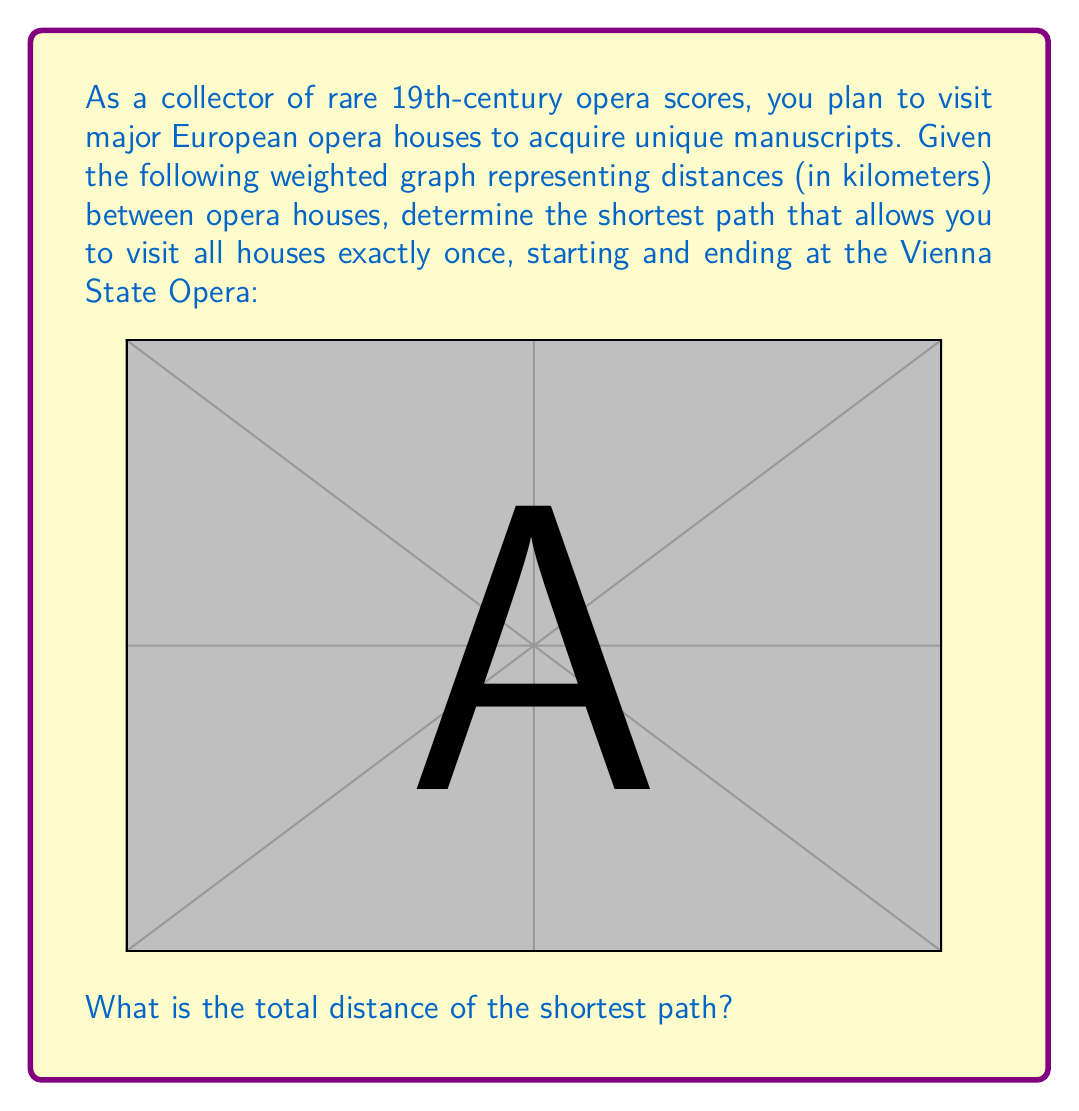Teach me how to tackle this problem. To solve this problem, we need to find the Hamiltonian cycle with the minimum total weight in the given graph. This is known as the Traveling Salesman Problem (TSP), which is NP-hard. For small graphs like this, we can use a brute-force approach to find the optimal solution.

Let's enumerate all possible Hamiltonian cycles starting and ending at Vienna:

1. Vienna -> Paris -> Milan -> Rome -> Munich -> Vienna
2. Vienna -> Paris -> Milan -> Munich -> Rome -> Vienna
3. Vienna -> Paris -> Rome -> Milan -> Munich -> Vienna
4. Vienna -> Paris -> Rome -> Munich -> Milan -> Vienna
5. Vienna -> Paris -> Munich -> Milan -> Rome -> Vienna
6. Vienna -> Paris -> Munich -> Rome -> Milan -> Vienna
7. Vienna -> Milan -> Paris -> Rome -> Munich -> Vienna
8. Vienna -> Milan -> Paris -> Munich -> Rome -> Vienna
9. Vienna -> Milan -> Rome -> Paris -> Munich -> Vienna
10. Vienna -> Milan -> Rome -> Munich -> Paris -> Vienna
11. Vienna -> Milan -> Munich -> Paris -> Rome -> Vienna
12. Vienna -> Milan -> Munich -> Rome -> Paris -> Vienna
13. Vienna -> Rome -> Paris -> Milan -> Munich -> Vienna
14. Vienna -> Rome -> Paris -> Munich -> Milan -> Vienna
15. Vienna -> Rome -> Milan -> Paris -> Munich -> Vienna
16. Vienna -> Rome -> Milan -> Munich -> Paris -> Vienna
17. Vienna -> Rome -> Munich -> Paris -> Milan -> Vienna
18. Vienna -> Rome -> Munich -> Milan -> Paris -> Vienna
19. Vienna -> Munich -> Paris -> Milan -> Rome -> Vienna
20. Vienna -> Munich -> Paris -> Rome -> Milan -> Vienna
21. Vienna -> Munich -> Milan -> Paris -> Rome -> Vienna
22. Vienna -> Munich -> Milan -> Rome -> Paris -> Vienna
23. Vienna -> Munich -> Rome -> Paris -> Milan -> Vienna
24. Vienna -> Munich -> Rome -> Milan -> Paris -> Vienna

Now, let's calculate the total distance for each path:

1. 1050 + 850 + 500 + 700 + 450 = 3550
2. 1050 + 850 + 600 + 700 + 1200 = 4400
3. 1050 + 1100 + 500 + 600 + 450 = 3700
4. 1050 + 1100 + 700 + 850 + 850 = 4550
5. 1050 + 800 + 600 + 500 + 1200 = 4150
6. 1050 + 800 + 700 + 500 + 850 = 3900
7. 850 + 850 + 1100 + 700 + 450 = 3950
8. 850 + 850 + 800 + 700 + 1200 = 4400
9. 850 + 500 + 1100 + 800 + 450 = 3700
10. 850 + 500 + 700 + 1050 + 850 = 3950
11. 850 + 600 + 800 + 1100 + 1200 = 4550
12. 850 + 600 + 700 + 1050 + 850 = 4050
13. 1200 + 1100 + 850 + 600 + 450 = 4200
14. 1200 + 1100 + 800 + 850 + 850 = 4800
15. 1200 + 500 + 850 + 800 + 450 = 3800
16. 1200 + 500 + 600 + 1050 + 850 = 4200
17. 1200 + 700 + 800 + 850 + 850 = 4400
18. 1200 + 700 + 600 + 850 + 850 = 4200
19. 450 + 800 + 850 + 500 + 1200 = 3800
20. 450 + 800 + 1100 + 500 + 850 = 3700
21. 450 + 600 + 850 + 1100 + 1200 = 4200
22. 450 + 600 + 500 + 1050 + 850 = 3450
23. 450 + 700 + 1100 + 850 + 850 = 3950
24. 450 + 700 + 500 + 850 + 850 = 3350

The shortest path is the last one (24), with a total distance of 3350 km.
Answer: The total distance of the shortest path is 3350 km, following the route: Vienna -> Munich -> Rome -> Milan -> Paris -> Vienna. 